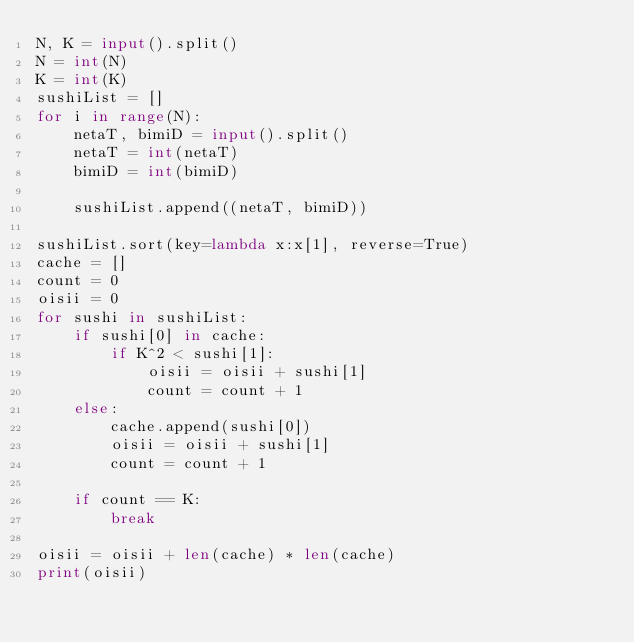<code> <loc_0><loc_0><loc_500><loc_500><_Python_>N, K = input().split()
N = int(N)
K = int(K)
sushiList = []
for i in range(N):
    netaT, bimiD = input().split()
    netaT = int(netaT)
    bimiD = int(bimiD)

    sushiList.append((netaT, bimiD))

sushiList.sort(key=lambda x:x[1], reverse=True)
cache = []
count = 0
oisii = 0
for sushi in sushiList:
    if sushi[0] in cache:
        if K^2 < sushi[1]:
            oisii = oisii + sushi[1]
            count = count + 1
    else:
        cache.append(sushi[0])
        oisii = oisii + sushi[1]
        count = count + 1

    if count == K:
        break

oisii = oisii + len(cache) * len(cache)
print(oisii)</code> 